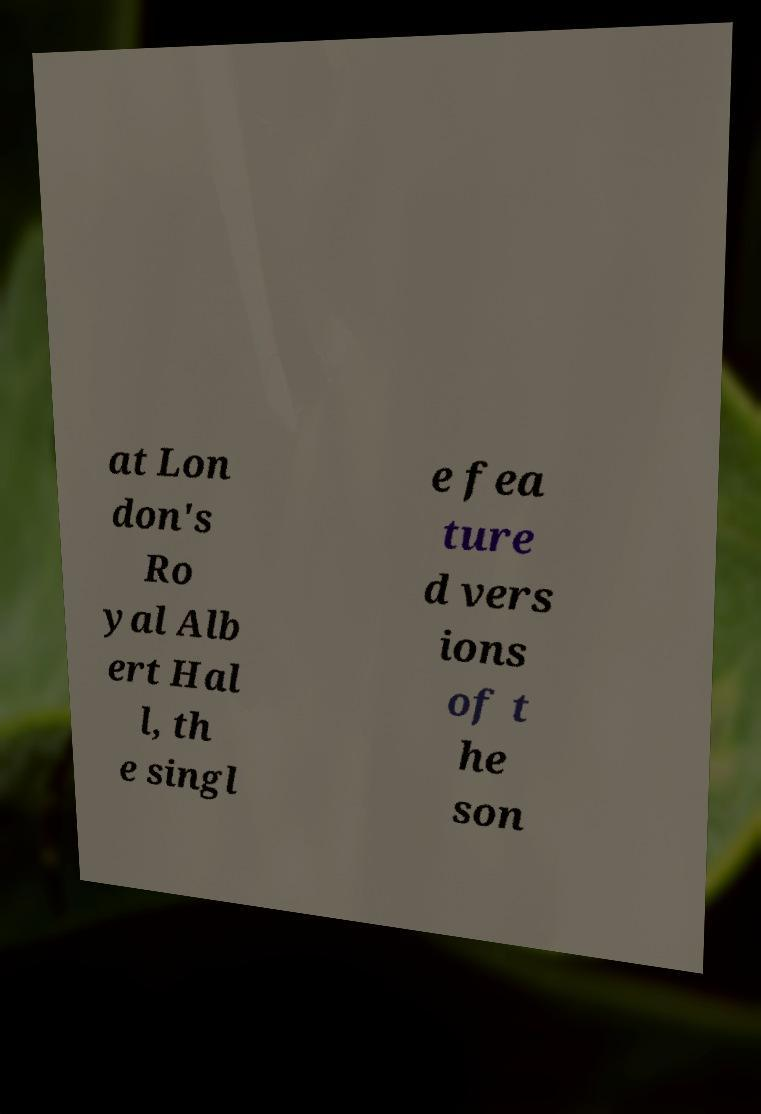Can you read and provide the text displayed in the image?This photo seems to have some interesting text. Can you extract and type it out for me? at Lon don's Ro yal Alb ert Hal l, th e singl e fea ture d vers ions of t he son 